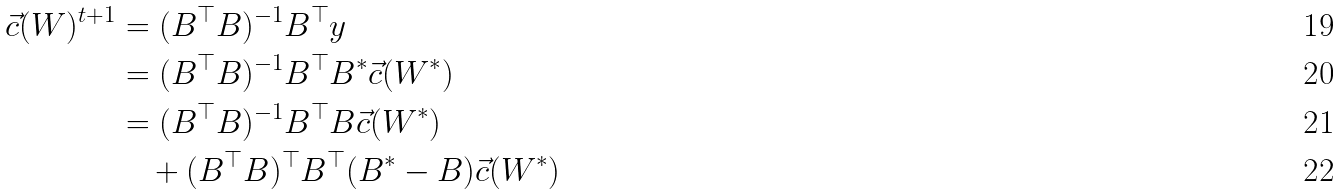Convert formula to latex. <formula><loc_0><loc_0><loc_500><loc_500>\vec { c } ( W ) ^ { t + 1 } & = ( B ^ { \top } B ) ^ { - 1 } B ^ { \top } y \\ & = ( B ^ { \top } B ) ^ { - 1 } B ^ { \top } B ^ { * } \vec { c } ( W ^ { * } ) \\ & = ( B ^ { \top } B ) ^ { - 1 } B ^ { \top } B \vec { c } ( W ^ { * } ) \\ & \quad + ( B ^ { \top } B ) ^ { \top } B ^ { \top } ( B ^ { * } - B ) \vec { c } ( W ^ { * } )</formula> 